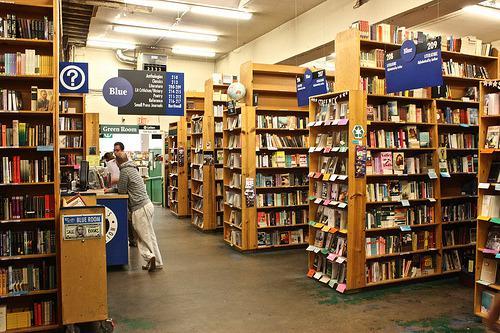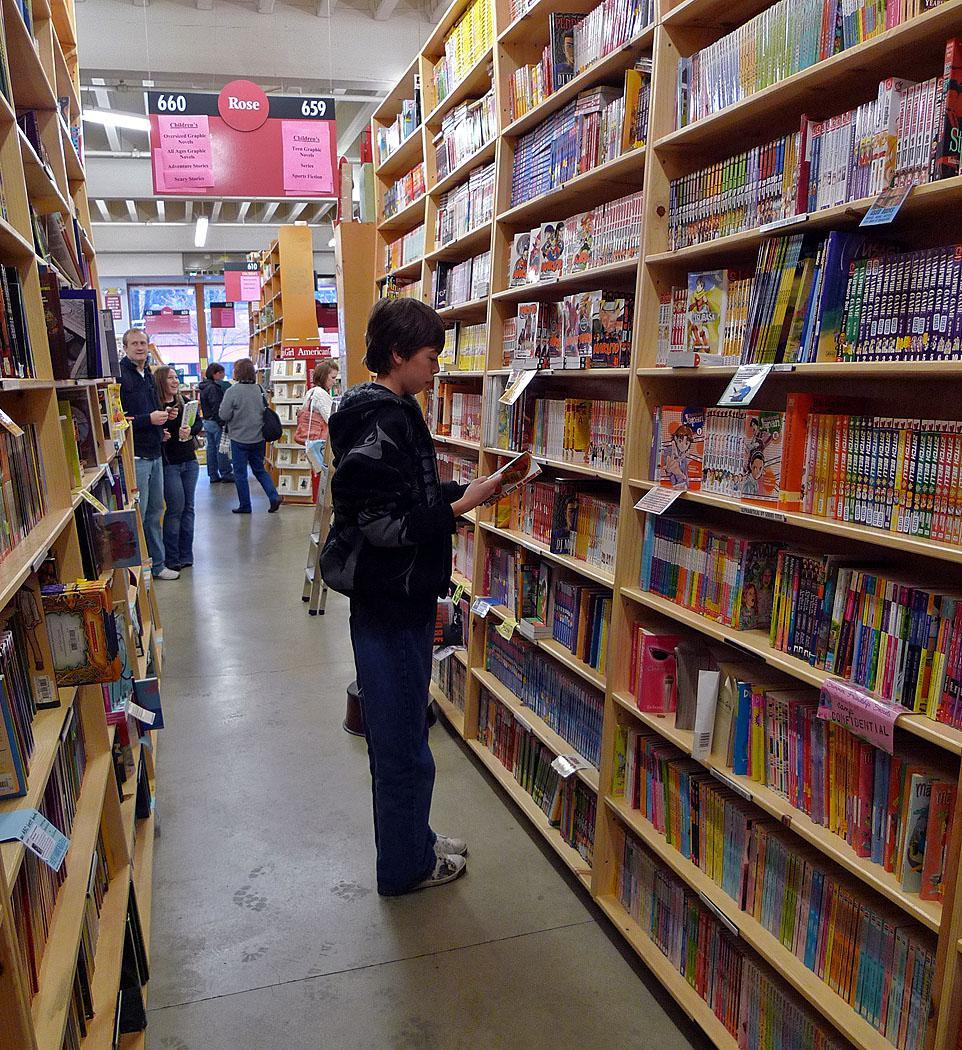The first image is the image on the left, the second image is the image on the right. Examine the images to the left and right. Is the description "One person is browsing at the bookshelf on the right side." accurate? Answer yes or no. Yes. The first image is the image on the left, the second image is the image on the right. Analyze the images presented: Is the assertion "In one image, a long gray pipe runs the length of the bookstore ceiling." valid? Answer yes or no. No. 